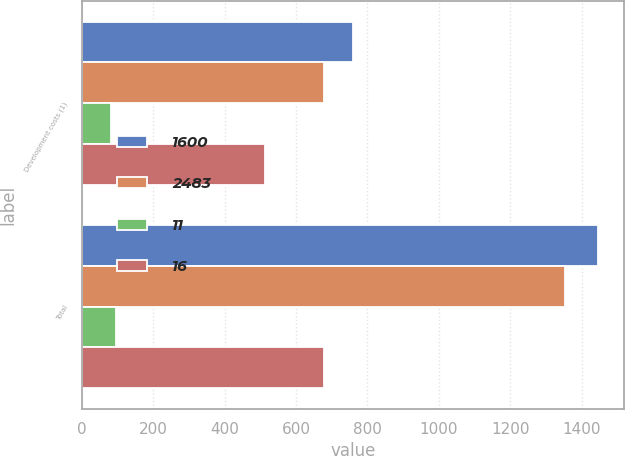Convert chart. <chart><loc_0><loc_0><loc_500><loc_500><stacked_bar_chart><ecel><fcel>Development costs (1)<fcel>Total<nl><fcel>1600<fcel>760<fcel>1447<nl><fcel>2483<fcel>679<fcel>1352<nl><fcel>11<fcel>81<fcel>95<nl><fcel>16<fcel>512<fcel>679<nl></chart> 